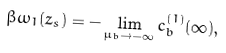Convert formula to latex. <formula><loc_0><loc_0><loc_500><loc_500>\beta \omega _ { 1 } ( z _ { s } ) = - \lim _ { \mu _ { b } \to - \infty } c _ { b } ^ { ( 1 ) } ( \infty ) ,</formula> 